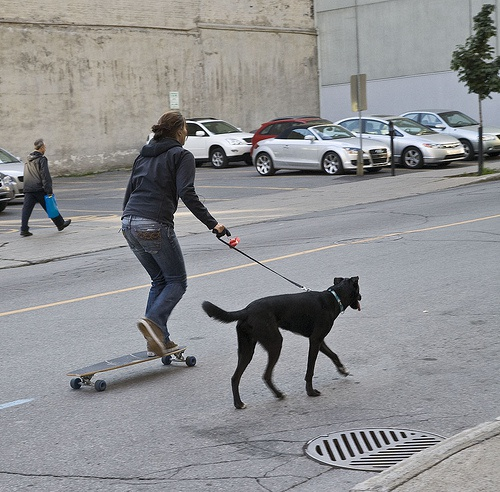Describe the objects in this image and their specific colors. I can see people in darkgray, black, and gray tones, dog in darkgray, black, gray, and lightgray tones, car in darkgray, lightgray, black, and gray tones, car in darkgray, lightgray, gray, and black tones, and car in darkgray, lightgray, black, and gray tones in this image. 